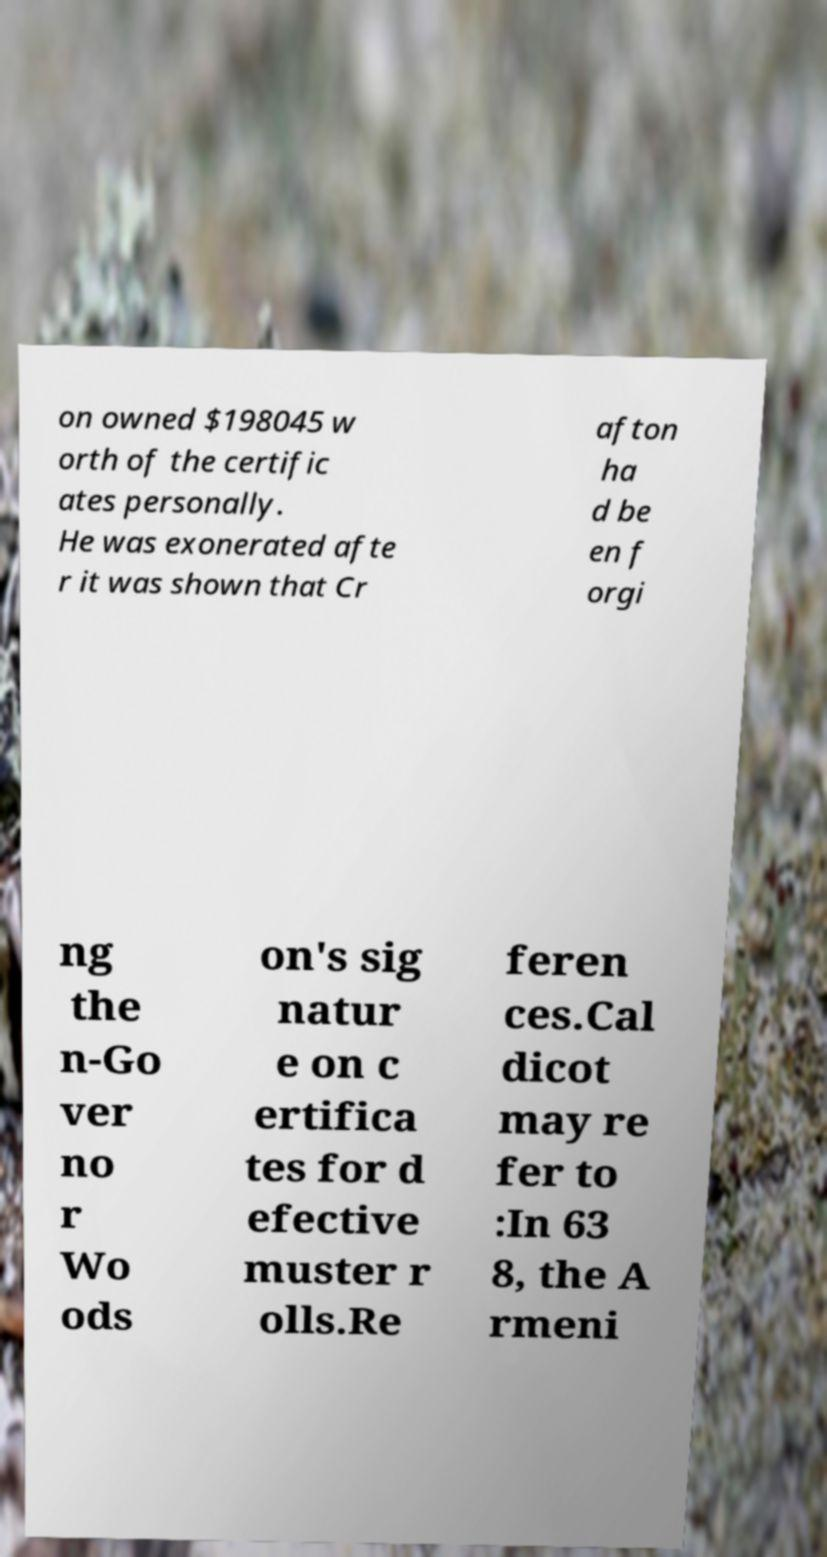Please read and relay the text visible in this image. What does it say? on owned $198045 w orth of the certific ates personally. He was exonerated afte r it was shown that Cr afton ha d be en f orgi ng the n-Go ver no r Wo ods on's sig natur e on c ertifica tes for d efective muster r olls.Re feren ces.Cal dicot may re fer to :In 63 8, the A rmeni 